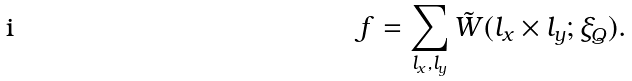Convert formula to latex. <formula><loc_0><loc_0><loc_500><loc_500>f = \sum _ { l _ { x } , l _ { y } } \tilde { W } ( l _ { x } \times l _ { y } ; \xi _ { Q } ) .</formula> 